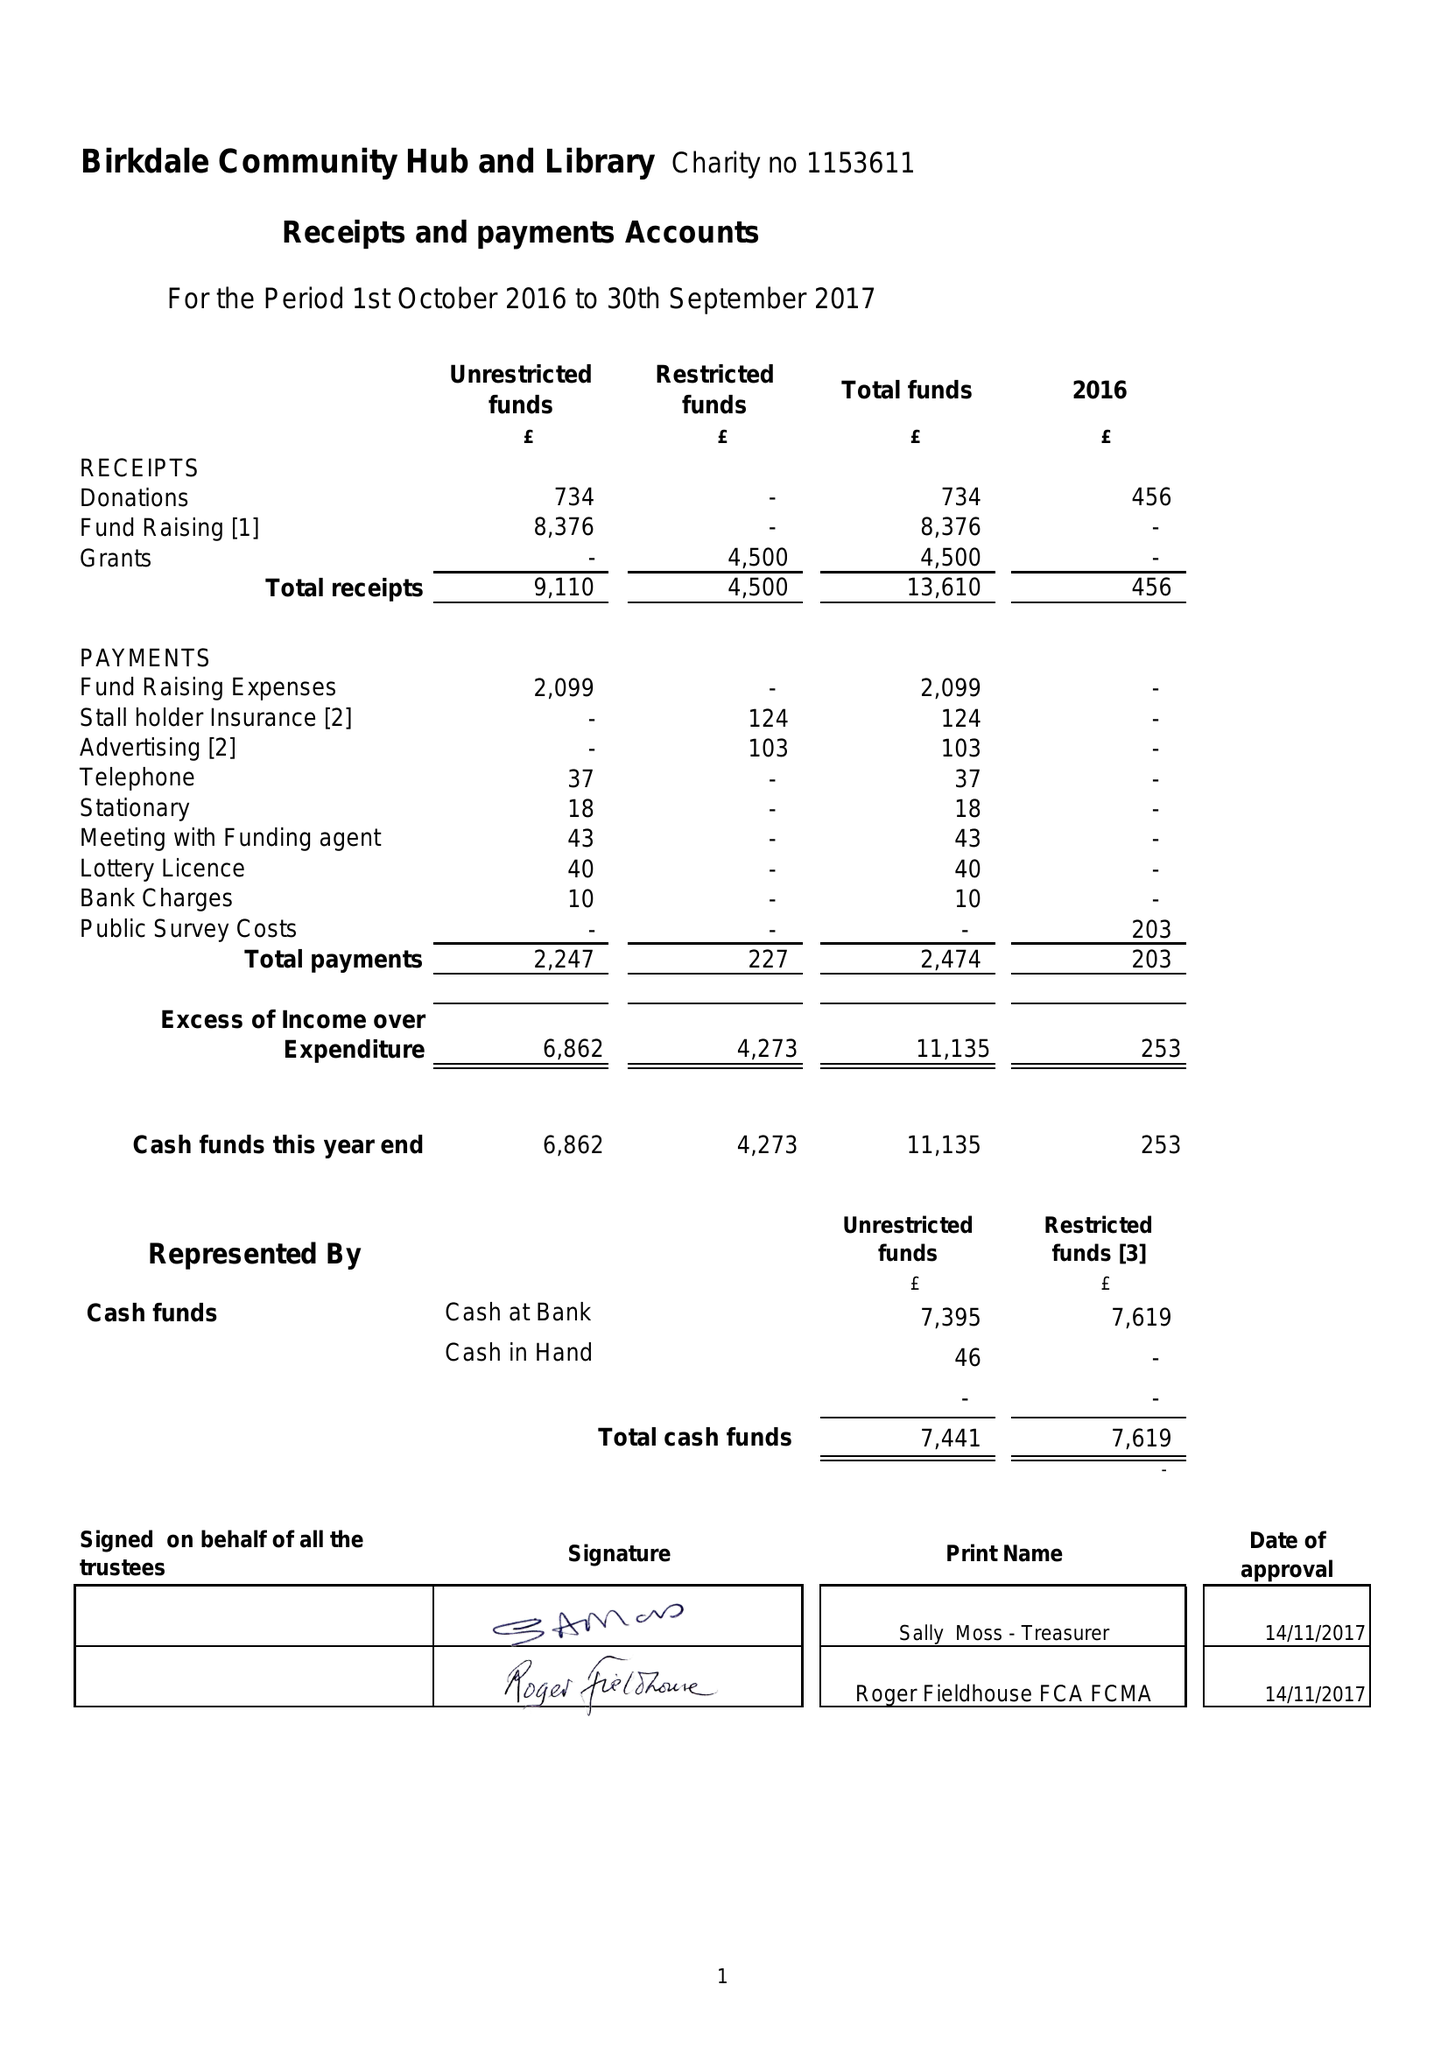What is the value for the spending_annually_in_british_pounds?
Answer the question using a single word or phrase. 2474.00 